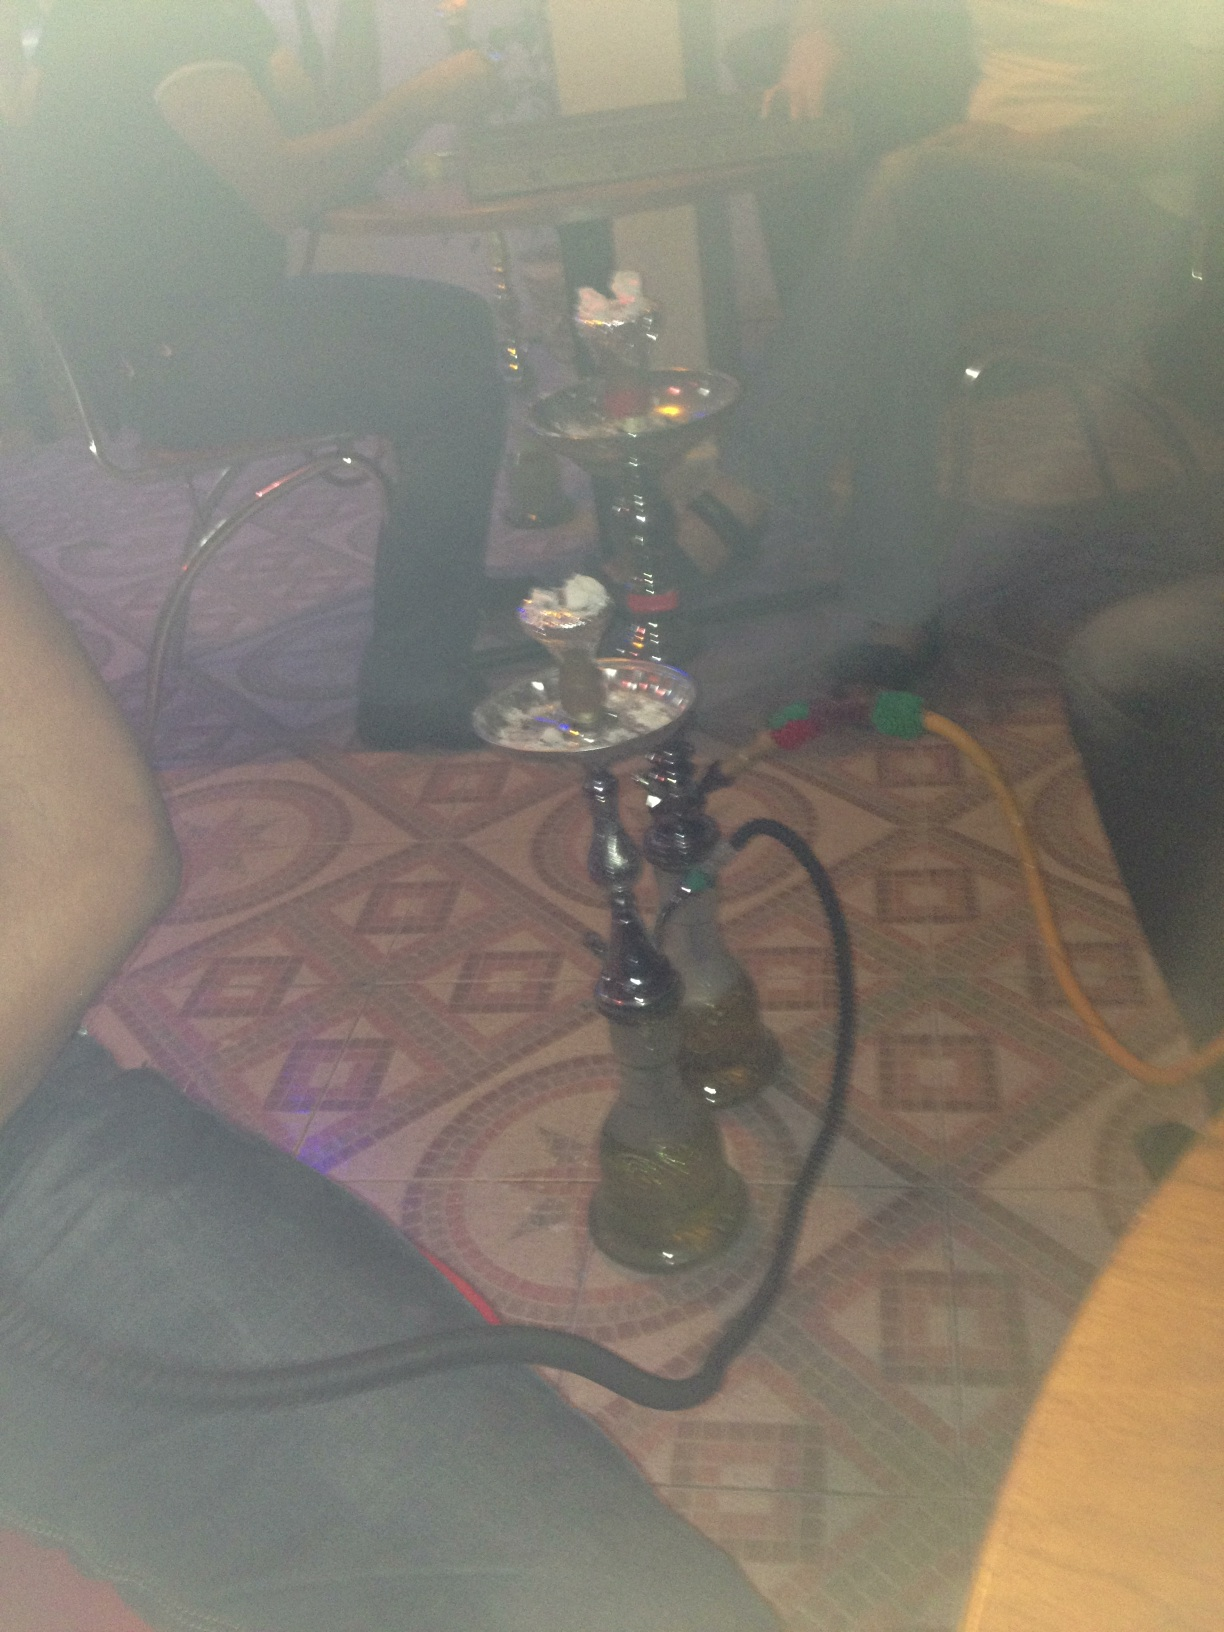What this? What this? from Vizwiz hookah 